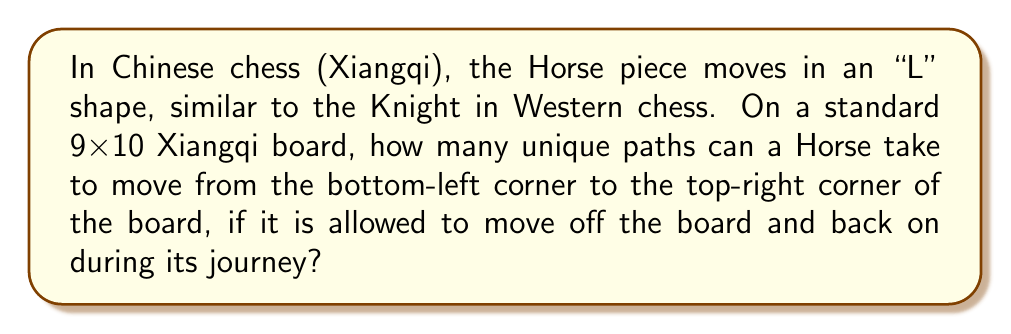Show me your answer to this math problem. Let's approach this step-by-step:

1) First, we need to understand the Horse's movement. It moves in an "L" shape: 2 squares in one direction and 1 square perpendicular to that.

2) To reach the top-right corner from the bottom-left corner, the Horse needs to move:
   - 8 steps to the right
   - 9 steps upward

3) Each move of the Horse contributes either 2 steps in one direction and 1 in the other, or vice versa. Let's define:
   - $a$: number of moves that contribute 2 steps right and 1 step up
   - $b$: number of moves that contribute 1 step right and 2 steps up

4) We can form two equations:
   $$2a + b = 8$$
   $$a + 2b = 9$$

5) Solving these equations:
   $2a + b = 8$
   $2a + 4b = 18$
   Subtracting, we get: $-3b = -10$
   Therefore, $b = \frac{10}{3}$

6) Since $b$ must be an integer, there is no solution where the Horse stays on the board at all times.

7) However, the question allows the Horse to move off the board and back on. In this case, we're essentially looking for the number of ways to arrange 8 right moves and 9 up moves in any order.

8) This becomes a combination problem. We need to choose the positions for either the 8 right moves or the 9 up moves out of the total 17 moves.

9) This can be calculated using the combination formula:
   $$\binom{17}{8} = \binom{17}{9} = \frac{17!}{8!9!}$$

10) Calculating this:
    $$\frac{17!}{8!9!} = \frac{17 \times 16 \times 15 \times 14 \times 13 \times 12 \times 11 \times 10}{8 \times 7 \times 6 \times 5 \times 4 \times 3 \times 2 \times 1} = 24310$$

Therefore, there are 24310 unique paths for the Horse to move from the bottom-left to the top-right corner.
Answer: 24310 